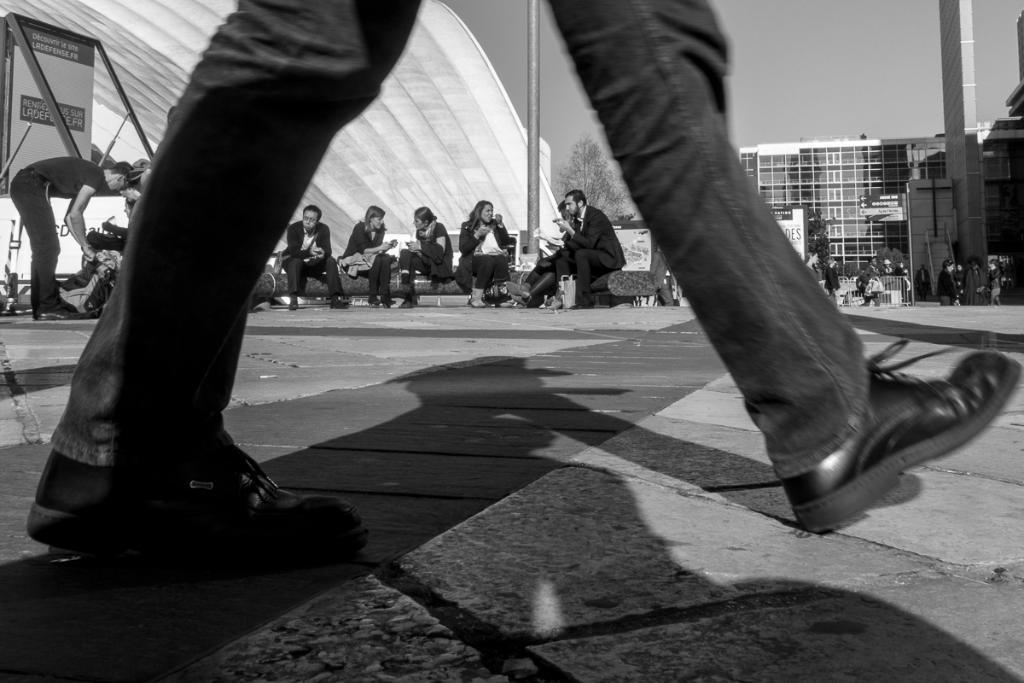Can you describe this image briefly? I can see this is a black and white picture. There are group of people, there are buildings, there is a tree and in the background there is sky. 